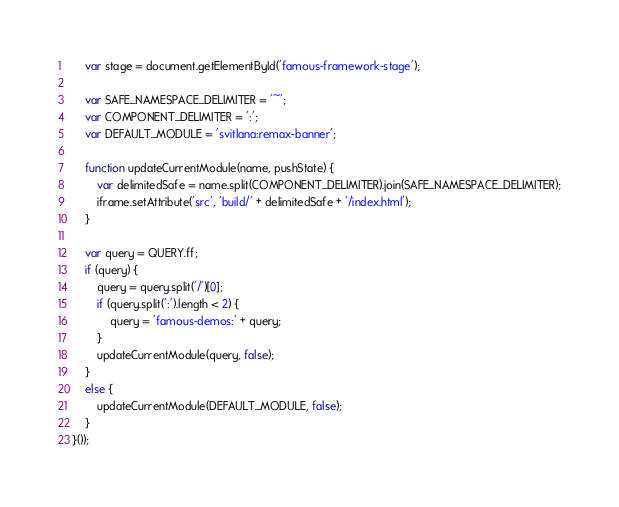<code> <loc_0><loc_0><loc_500><loc_500><_JavaScript_>    var stage = document.getElementById('famous-framework-stage');

    var SAFE_NAMESPACE_DELIMITER = '~';
    var COMPONENT_DELIMITER = ':';
    var DEFAULT_MODULE = 'svitlana:remax-banner';

    function updateCurrentModule(name, pushState) {
        var delimitedSafe = name.split(COMPONENT_DELIMITER).join(SAFE_NAMESPACE_DELIMITER);
        iframe.setAttribute('src', 'build/' + delimitedSafe + '/index.html');
    }

    var query = QUERY.ff;
    if (query) {
        query = query.split('/')[0];
        if (query.split(':').length < 2) {
            query = 'famous-demos:' + query;
        }
        updateCurrentModule(query, false);
    }
    else {
        updateCurrentModule(DEFAULT_MODULE, false);
    }
}());
</code> 